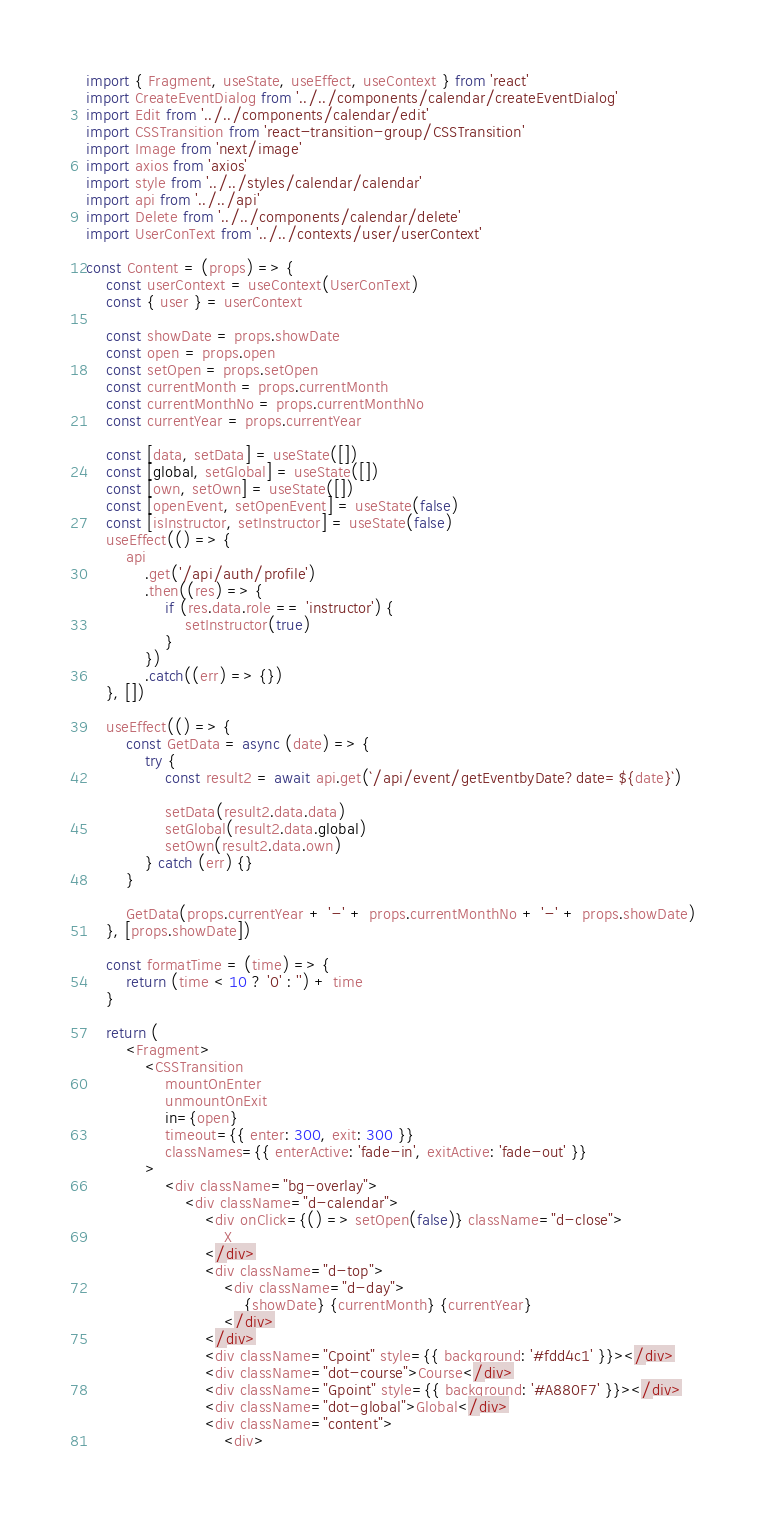<code> <loc_0><loc_0><loc_500><loc_500><_JavaScript_>import { Fragment, useState, useEffect, useContext } from 'react'
import CreateEventDialog from '../../components/calendar/createEventDialog'
import Edit from '../../components/calendar/edit'
import CSSTransition from 'react-transition-group/CSSTransition'
import Image from 'next/image'
import axios from 'axios'
import style from '../../styles/calendar/calendar'
import api from '../../api'
import Delete from '../../components/calendar/delete'
import UserConText from '../../contexts/user/userContext'

const Content = (props) => {
	const userContext = useContext(UserConText)
	const { user } = userContext

	const showDate = props.showDate
	const open = props.open
	const setOpen = props.setOpen
	const currentMonth = props.currentMonth
	const currentMonthNo = props.currentMonthNo
	const currentYear = props.currentYear

	const [data, setData] = useState([])
	const [global, setGlobal] = useState([])
	const [own, setOwn] = useState([])
	const [openEvent, setOpenEvent] = useState(false)
	const [isInstructor, setInstructor] = useState(false)
	useEffect(() => {
		api
			.get('/api/auth/profile')
			.then((res) => {
				if (res.data.role == 'instructor') {
					setInstructor(true)
				}
			})
			.catch((err) => {})
	}, [])

	useEffect(() => {
		const GetData = async (date) => {
			try {
				const result2 = await api.get(`/api/event/getEventbyDate?date=${date}`)

				setData(result2.data.data)
				setGlobal(result2.data.global)
				setOwn(result2.data.own)
			} catch (err) {}
		}

		GetData(props.currentYear + '-' + props.currentMonthNo + '-' + props.showDate)
	}, [props.showDate])

	const formatTime = (time) => {
		return (time < 10 ? '0' : '') + time
	}

	return (
		<Fragment>
			<CSSTransition
				mountOnEnter
				unmountOnExit
				in={open}
				timeout={{ enter: 300, exit: 300 }}
				classNames={{ enterActive: 'fade-in', exitActive: 'fade-out' }}
			>
				<div className="bg-overlay">
					<div className="d-calendar">
						<div onClick={() => setOpen(false)} className="d-close">
							X
						</div>
						<div className="d-top">
							<div className="d-day">
								{showDate} {currentMonth} {currentYear}
							</div>
						</div>
						<div className="Cpoint" style={{ background: '#fdd4c1' }}></div>
						<div className="dot-course">Course</div>
						<div className="Gpoint" style={{ background: '#A880F7' }}></div>
						<div className="dot-global">Global</div>
						<div className="content">
							<div></code> 